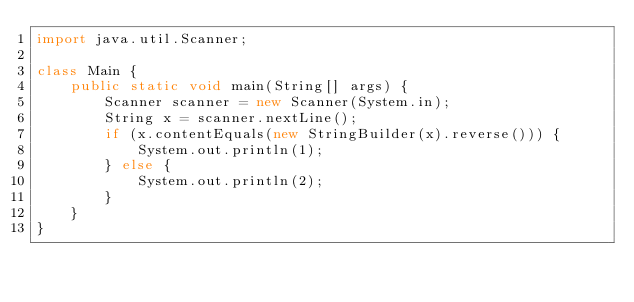Convert code to text. <code><loc_0><loc_0><loc_500><loc_500><_Java_>import java.util.Scanner;

class Main {
    public static void main(String[] args) {
        Scanner scanner = new Scanner(System.in);
        String x = scanner.nextLine();
        if (x.contentEquals(new StringBuilder(x).reverse())) {
            System.out.println(1);
        } else {
            System.out.println(2);
        }
    }
}</code> 